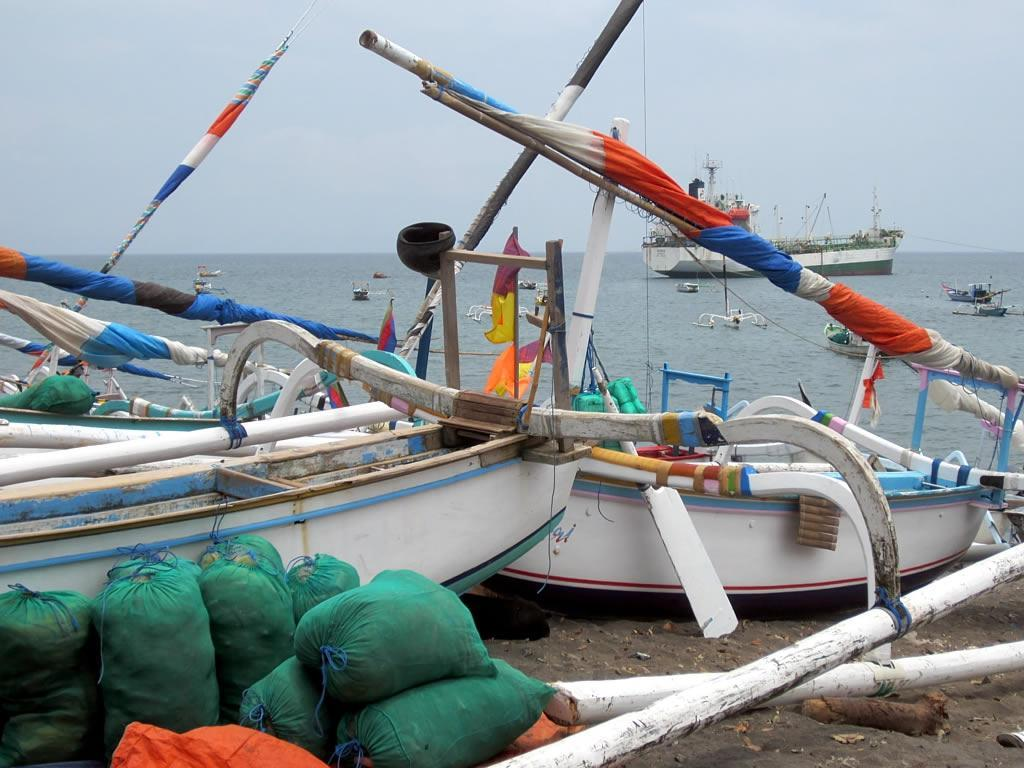What is in the water in the image? There are boats in the water. What is the condition of the sky in the image? The sky is cloudy. Where are some of the boats located in the image? There are boats on the seashore. What objects can be seen on the ground in the image? There are bags on the ground. Can you see any sheets hanging from the boats in the image? There are no sheets visible in the image; it features boats in the water and on the seashore. Are there any icicles hanging from the boats in the image? There are no icicles present in the image, as it is not a cold or icy environment. 